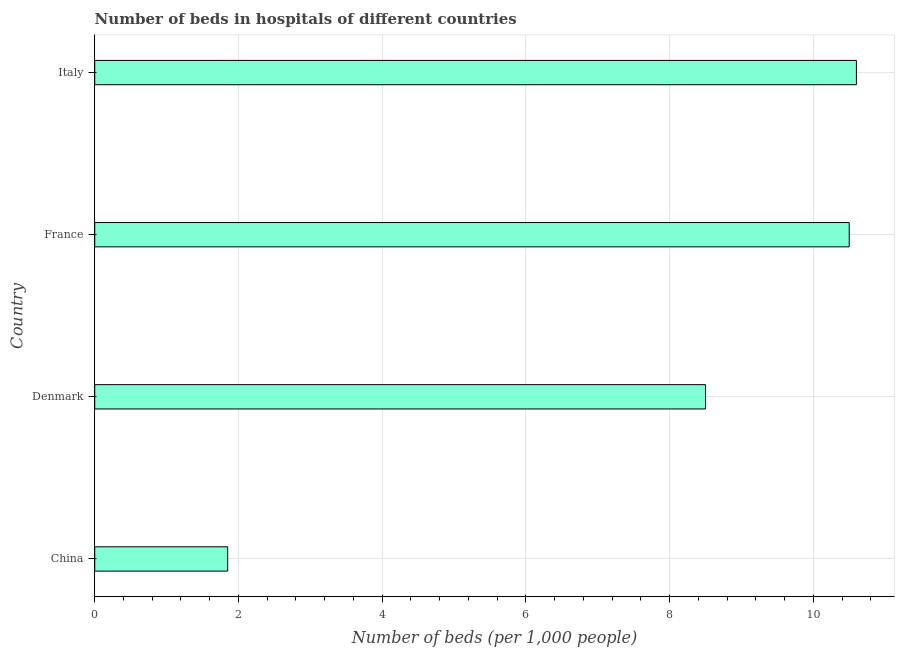Does the graph contain grids?
Provide a short and direct response. Yes. What is the title of the graph?
Keep it short and to the point. Number of beds in hospitals of different countries. What is the label or title of the X-axis?
Your answer should be compact. Number of beds (per 1,0 people). What is the label or title of the Y-axis?
Keep it short and to the point. Country. What is the number of hospital beds in China?
Your response must be concise. 1.85. Across all countries, what is the maximum number of hospital beds?
Offer a very short reply. 10.6. Across all countries, what is the minimum number of hospital beds?
Your answer should be very brief. 1.85. In which country was the number of hospital beds maximum?
Your answer should be compact. Italy. What is the sum of the number of hospital beds?
Offer a very short reply. 31.45. What is the difference between the number of hospital beds in China and France?
Offer a terse response. -8.65. What is the average number of hospital beds per country?
Provide a succinct answer. 7.86. In how many countries, is the number of hospital beds greater than 6.4 %?
Provide a succinct answer. 3. What is the ratio of the number of hospital beds in China to that in Denmark?
Provide a succinct answer. 0.22. Is the number of hospital beds in France less than that in Italy?
Offer a terse response. Yes. Is the sum of the number of hospital beds in China and France greater than the maximum number of hospital beds across all countries?
Provide a succinct answer. Yes. What is the difference between the highest and the lowest number of hospital beds?
Provide a short and direct response. 8.75. In how many countries, is the number of hospital beds greater than the average number of hospital beds taken over all countries?
Offer a very short reply. 3. Are all the bars in the graph horizontal?
Your response must be concise. Yes. How many countries are there in the graph?
Keep it short and to the point. 4. Are the values on the major ticks of X-axis written in scientific E-notation?
Keep it short and to the point. No. What is the Number of beds (per 1,000 people) in China?
Your response must be concise. 1.85. What is the Number of beds (per 1,000 people) of France?
Your answer should be very brief. 10.5. What is the Number of beds (per 1,000 people) in Italy?
Keep it short and to the point. 10.6. What is the difference between the Number of beds (per 1,000 people) in China and Denmark?
Give a very brief answer. -6.65. What is the difference between the Number of beds (per 1,000 people) in China and France?
Make the answer very short. -8.65. What is the difference between the Number of beds (per 1,000 people) in China and Italy?
Offer a very short reply. -8.75. What is the difference between the Number of beds (per 1,000 people) in Denmark and Italy?
Ensure brevity in your answer.  -2.1. What is the difference between the Number of beds (per 1,000 people) in France and Italy?
Give a very brief answer. -0.1. What is the ratio of the Number of beds (per 1,000 people) in China to that in Denmark?
Keep it short and to the point. 0.22. What is the ratio of the Number of beds (per 1,000 people) in China to that in France?
Make the answer very short. 0.18. What is the ratio of the Number of beds (per 1,000 people) in China to that in Italy?
Provide a succinct answer. 0.17. What is the ratio of the Number of beds (per 1,000 people) in Denmark to that in France?
Your response must be concise. 0.81. What is the ratio of the Number of beds (per 1,000 people) in Denmark to that in Italy?
Your answer should be very brief. 0.8. 